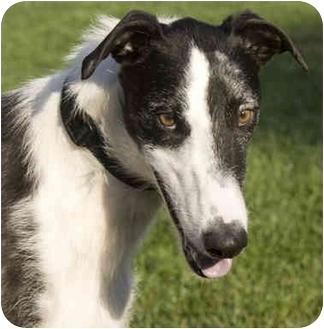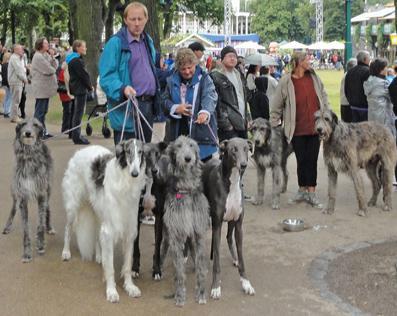The first image is the image on the left, the second image is the image on the right. Examine the images to the left and right. Is the description "There are exactly two dogs in total." accurate? Answer yes or no. No. The first image is the image on the left, the second image is the image on the right. For the images displayed, is the sentence "An image includes at least one person standing behind a standing afghan hound outdoors." factually correct? Answer yes or no. Yes. 